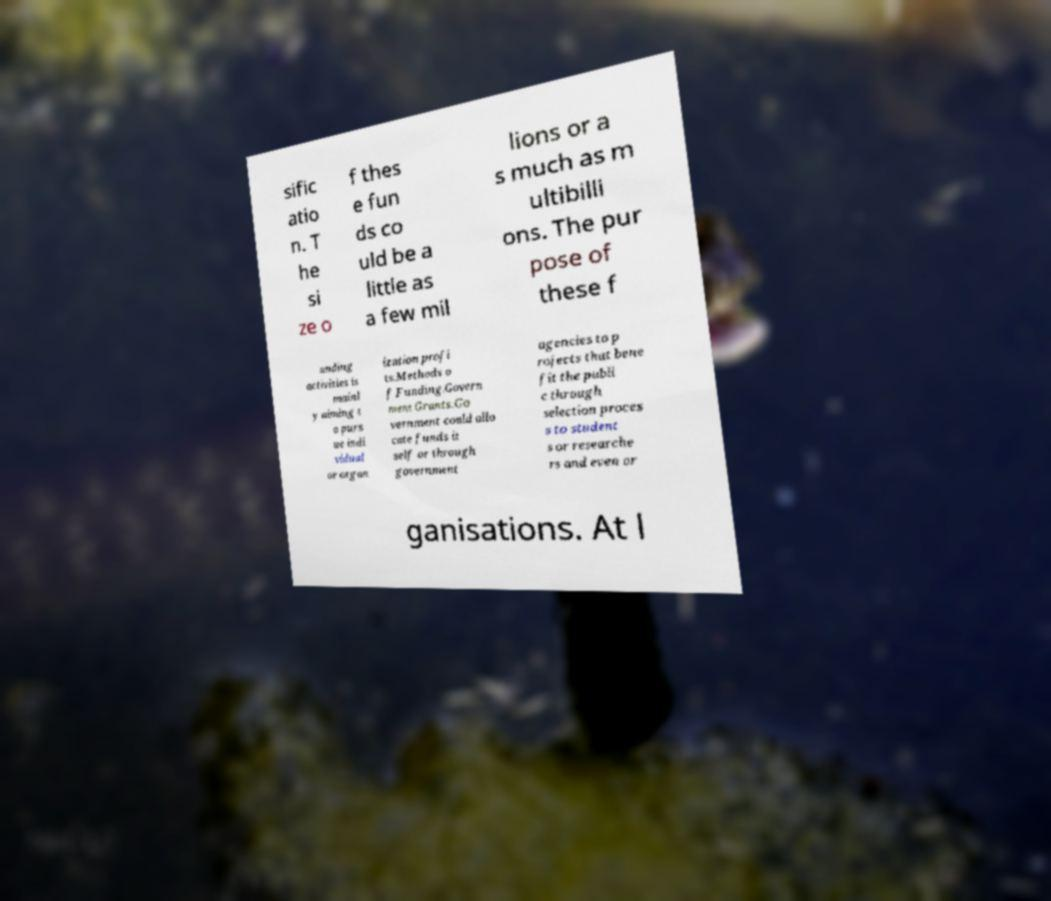What messages or text are displayed in this image? I need them in a readable, typed format. sific atio n. T he si ze o f thes e fun ds co uld be a little as a few mil lions or a s much as m ultibilli ons. The pur pose of these f unding activities is mainl y aiming t o purs ue indi vidual or organ ization profi ts.Methods o f Funding.Govern ment Grants.Go vernment could allo cate funds it self or through government agencies to p rojects that bene fit the publi c through selection proces s to student s or researche rs and even or ganisations. At l 